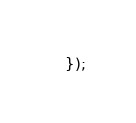Convert code to text. <code><loc_0><loc_0><loc_500><loc_500><_JavaScript_>});
</code> 